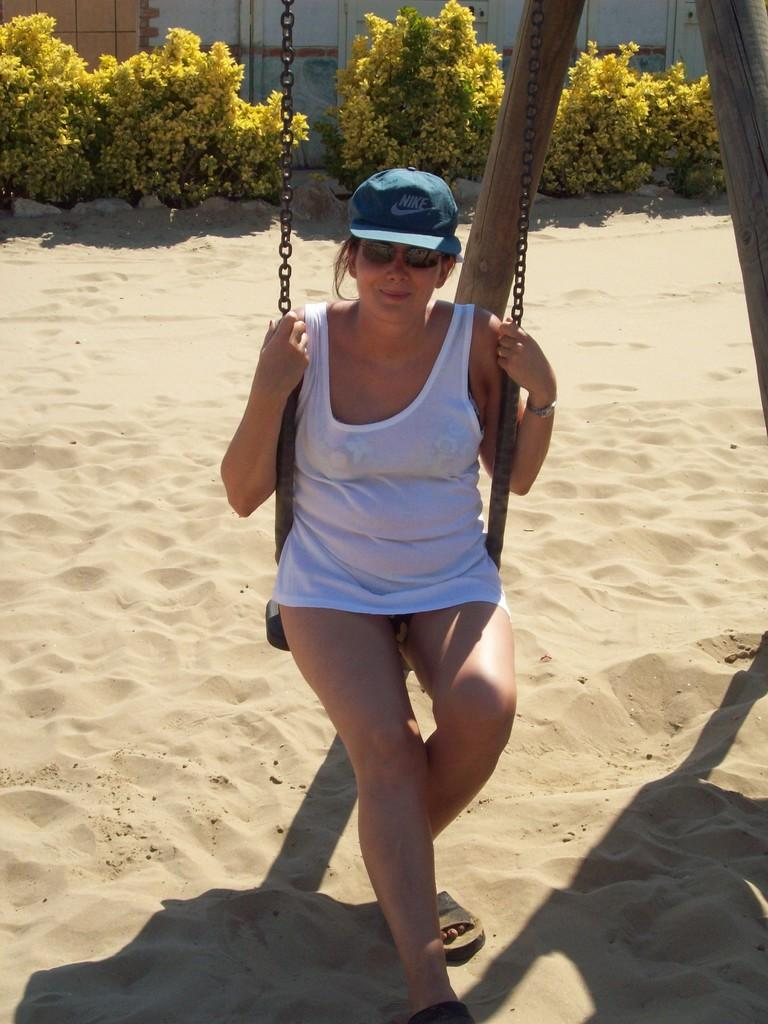Who is the main subject in the image? There is a woman in the image. What is the woman doing in the image? The woman is sitting on a swing. What can be seen in the background of the image? There are plants and sand visible in the background of the image. What type of ink can be seen dripping from the woman's boot in the image? There is no ink or boot present in the image; the woman is sitting on a swing, and there are plants and sand visible in the background. 